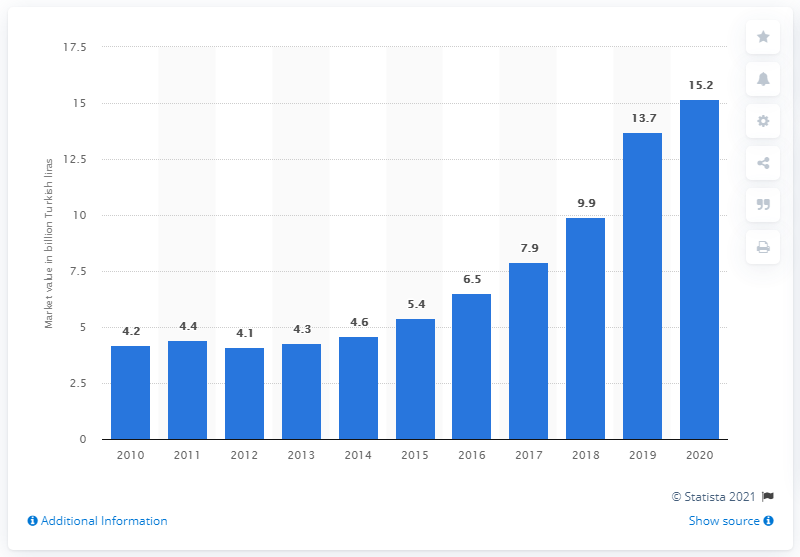Mention a couple of crucial points in this snapshot. In 2012, the generics market in Turkey was valued at approximately 4.1 billion dollars. 